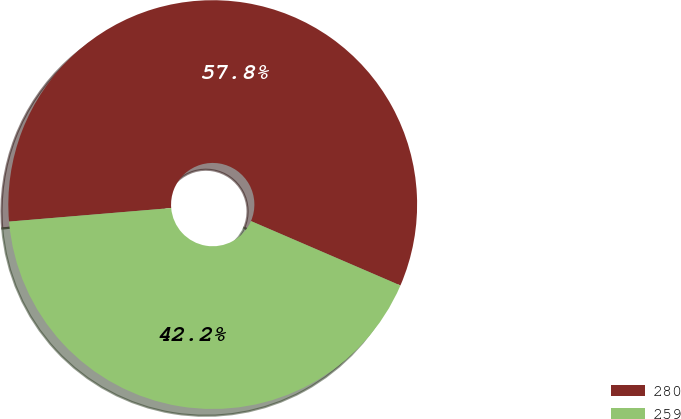Convert chart. <chart><loc_0><loc_0><loc_500><loc_500><pie_chart><fcel>280<fcel>259<nl><fcel>57.8%<fcel>42.2%<nl></chart> 